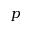Convert formula to latex. <formula><loc_0><loc_0><loc_500><loc_500>p</formula> 